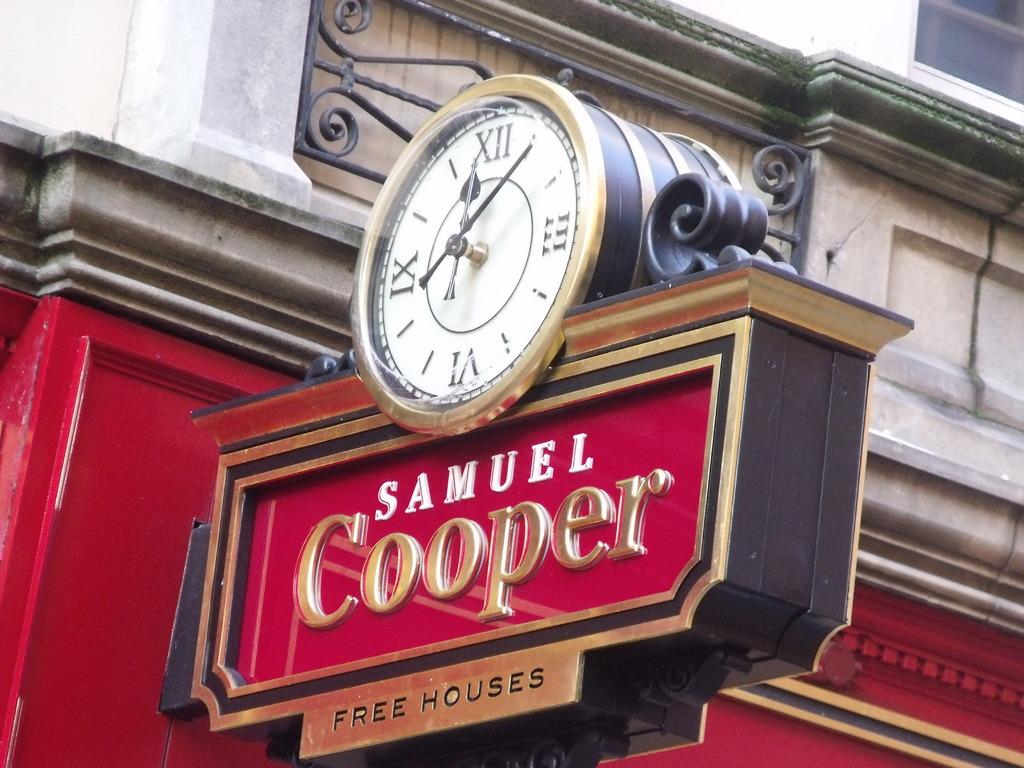What is the name on this sign?
Offer a terse response. Samuel cooper. What is the time on?
Offer a terse response. 12:05. 